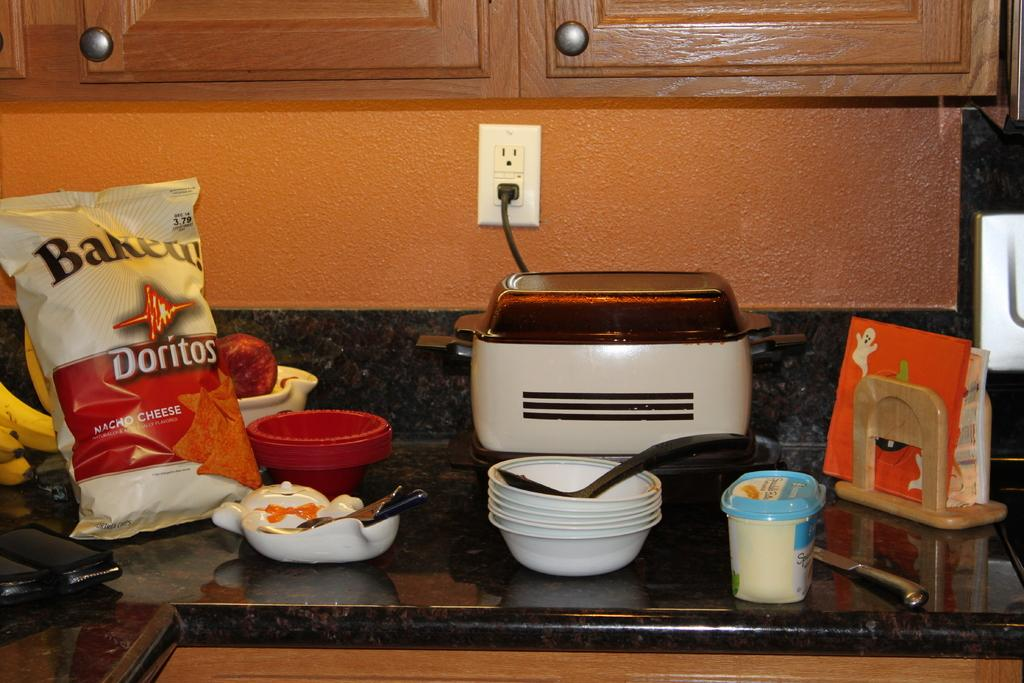<image>
Provide a brief description of the given image. a kitchen counter with a doritos bag on it 